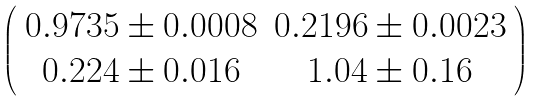<formula> <loc_0><loc_0><loc_500><loc_500>\left ( \begin{array} { c c } 0 . 9 7 3 5 \pm 0 . 0 0 0 8 & 0 . 2 1 9 6 \pm 0 . 0 0 2 3 \\ 0 . 2 2 4 \pm 0 . 0 1 6 & 1 . 0 4 \pm 0 . 1 6 \end{array} \right )</formula> 